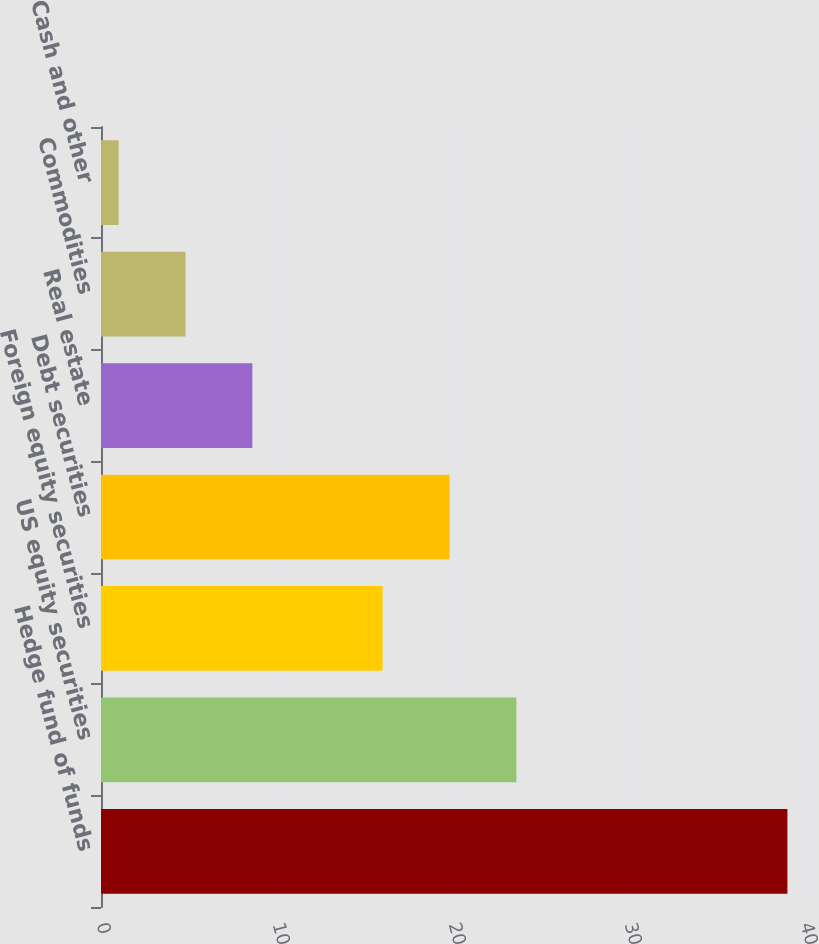<chart> <loc_0><loc_0><loc_500><loc_500><bar_chart><fcel>Hedge fund of funds<fcel>US equity securities<fcel>Foreign equity securities<fcel>Debt securities<fcel>Real estate<fcel>Commodities<fcel>Cash and other<nl><fcel>39<fcel>23.6<fcel>16<fcel>19.8<fcel>8.6<fcel>4.8<fcel>1<nl></chart> 